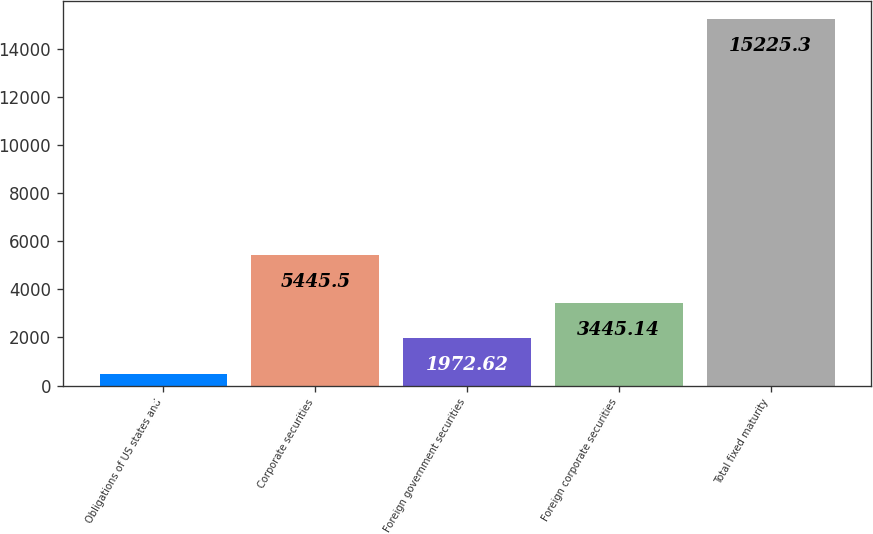Convert chart to OTSL. <chart><loc_0><loc_0><loc_500><loc_500><bar_chart><fcel>Obligations of US states and<fcel>Corporate securities<fcel>Foreign government securities<fcel>Foreign corporate securities<fcel>Total fixed maturity<nl><fcel>500.1<fcel>5445.5<fcel>1972.62<fcel>3445.14<fcel>15225.3<nl></chart> 